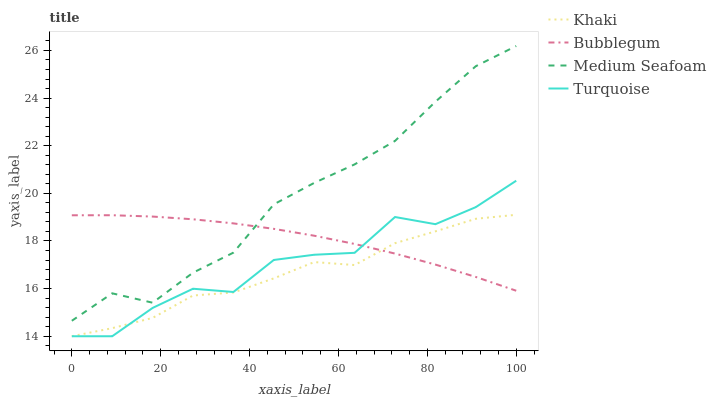Does Khaki have the minimum area under the curve?
Answer yes or no. Yes. Does Medium Seafoam have the maximum area under the curve?
Answer yes or no. Yes. Does Medium Seafoam have the minimum area under the curve?
Answer yes or no. No. Does Khaki have the maximum area under the curve?
Answer yes or no. No. Is Bubblegum the smoothest?
Answer yes or no. Yes. Is Turquoise the roughest?
Answer yes or no. Yes. Is Khaki the smoothest?
Answer yes or no. No. Is Khaki the roughest?
Answer yes or no. No. Does Medium Seafoam have the lowest value?
Answer yes or no. No. Does Medium Seafoam have the highest value?
Answer yes or no. Yes. Does Khaki have the highest value?
Answer yes or no. No. Is Turquoise less than Medium Seafoam?
Answer yes or no. Yes. Is Medium Seafoam greater than Khaki?
Answer yes or no. Yes. Does Bubblegum intersect Khaki?
Answer yes or no. Yes. Is Bubblegum less than Khaki?
Answer yes or no. No. Is Bubblegum greater than Khaki?
Answer yes or no. No. Does Turquoise intersect Medium Seafoam?
Answer yes or no. No. 